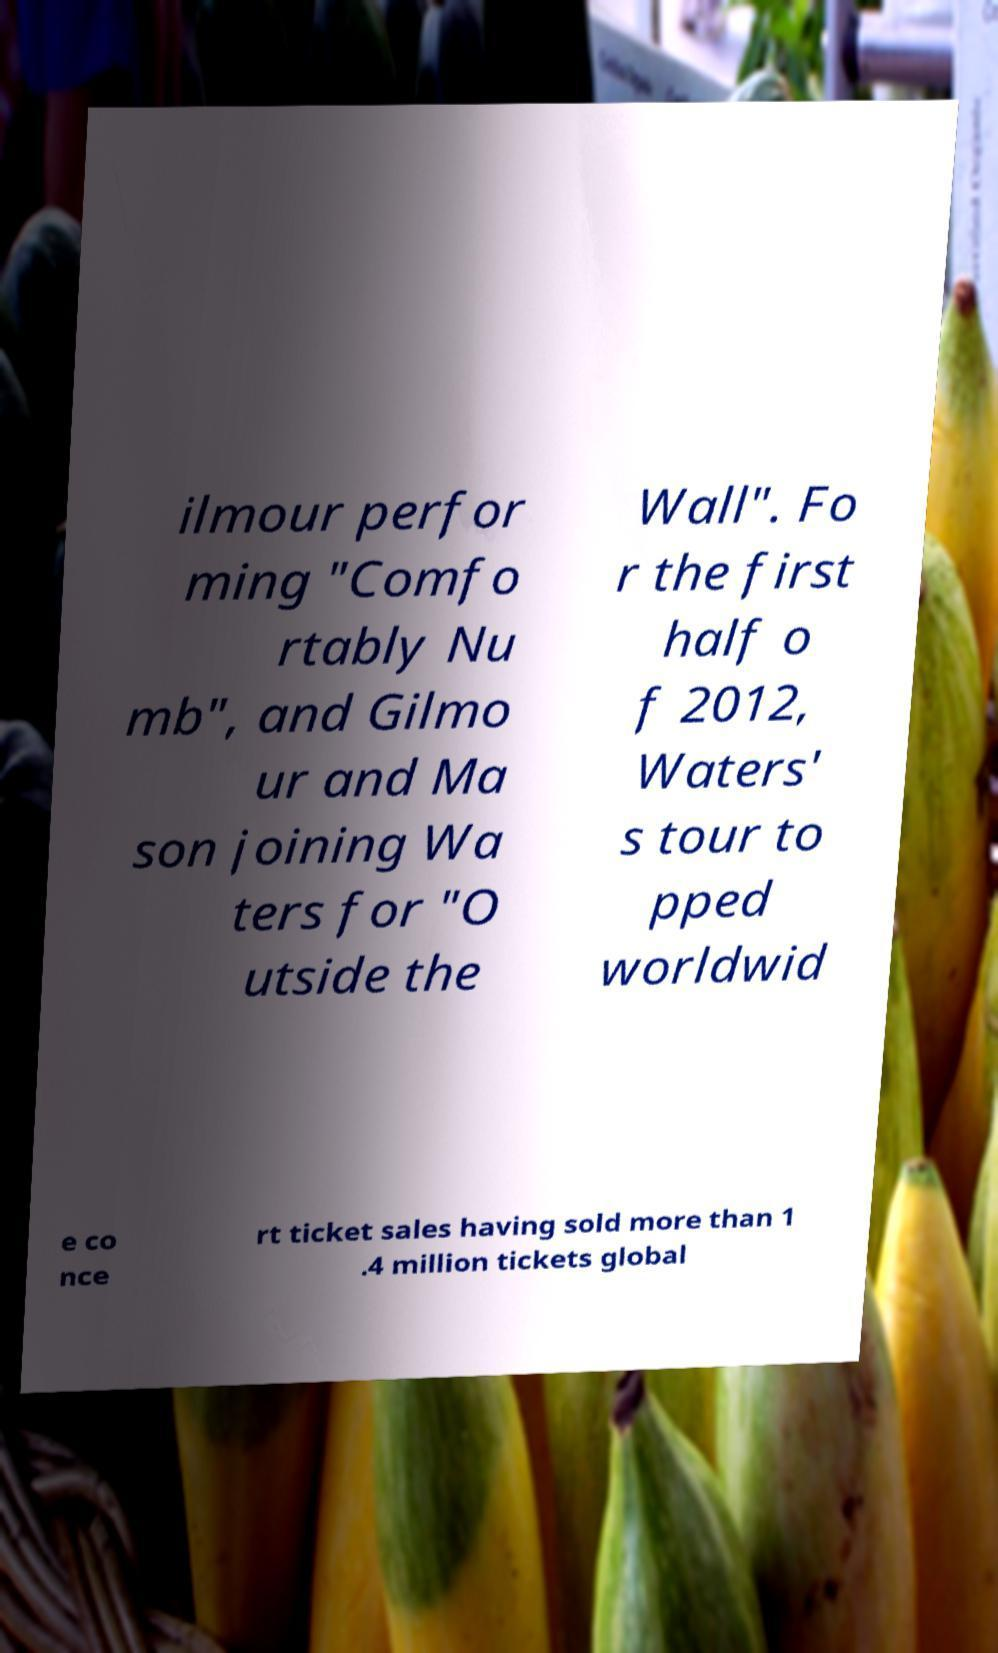Please read and relay the text visible in this image. What does it say? ilmour perfor ming "Comfo rtably Nu mb", and Gilmo ur and Ma son joining Wa ters for "O utside the Wall". Fo r the first half o f 2012, Waters' s tour to pped worldwid e co nce rt ticket sales having sold more than 1 .4 million tickets global 